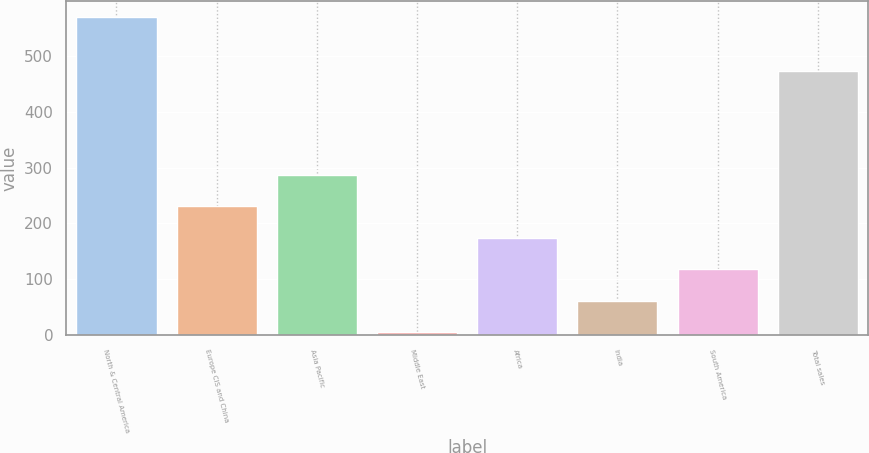<chart> <loc_0><loc_0><loc_500><loc_500><bar_chart><fcel>North & Central America<fcel>Europe CIS and China<fcel>Asia Pacific<fcel>Middle East<fcel>Africa<fcel>India<fcel>South America<fcel>Total sales<nl><fcel>569<fcel>230.6<fcel>287<fcel>5<fcel>174.2<fcel>61.4<fcel>117.8<fcel>472<nl></chart> 